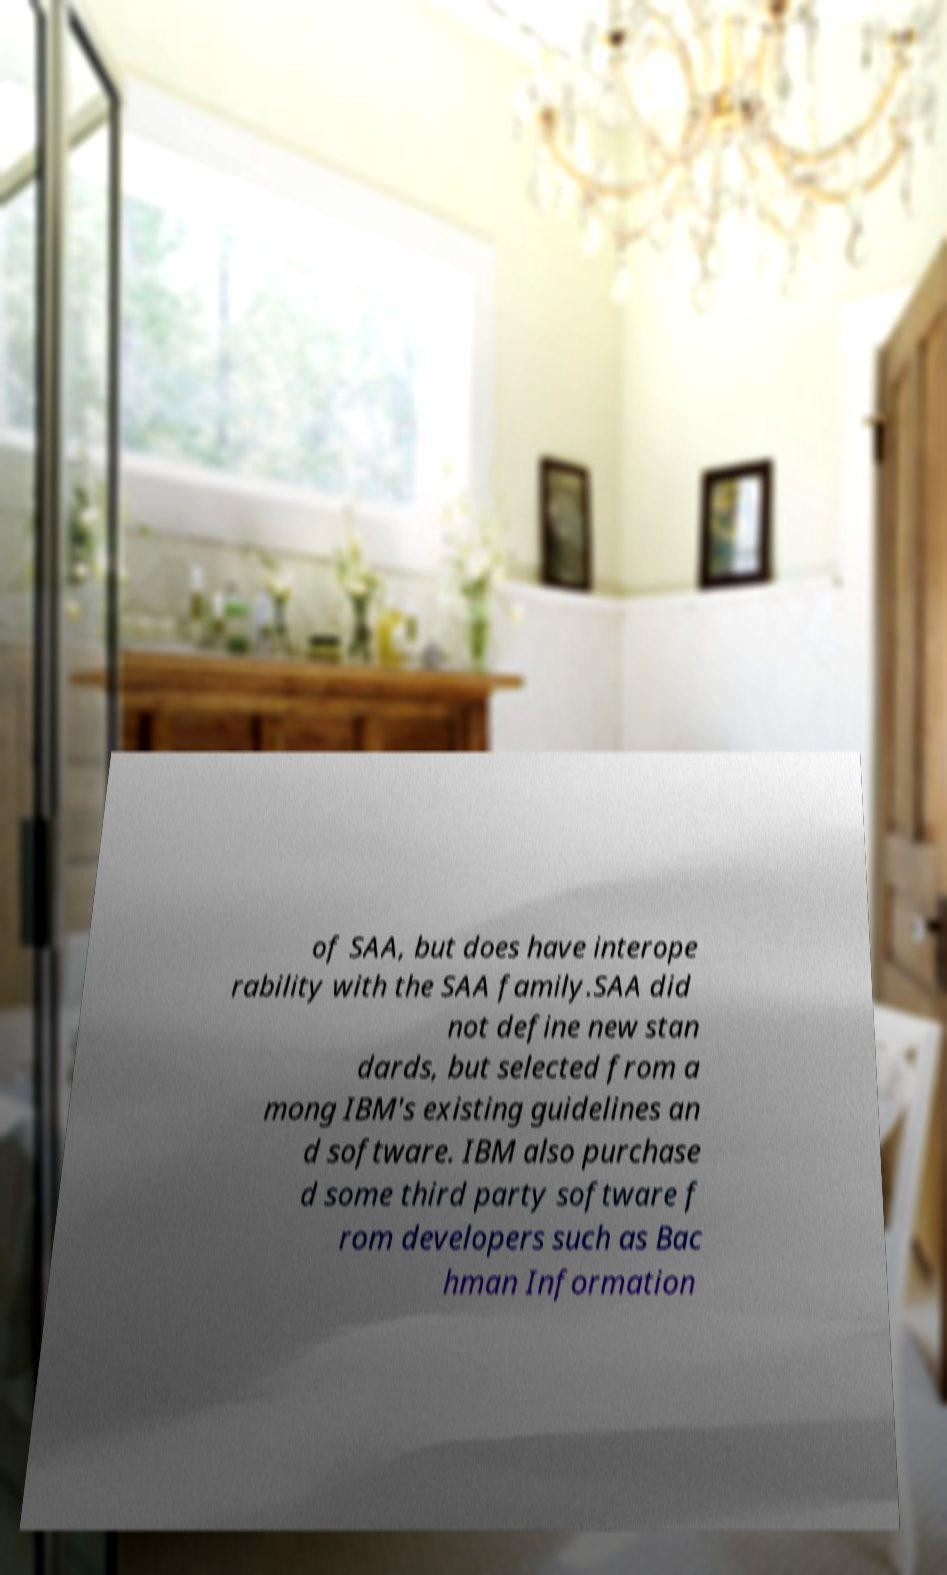Can you read and provide the text displayed in the image?This photo seems to have some interesting text. Can you extract and type it out for me? of SAA, but does have interope rability with the SAA family.SAA did not define new stan dards, but selected from a mong IBM's existing guidelines an d software. IBM also purchase d some third party software f rom developers such as Bac hman Information 